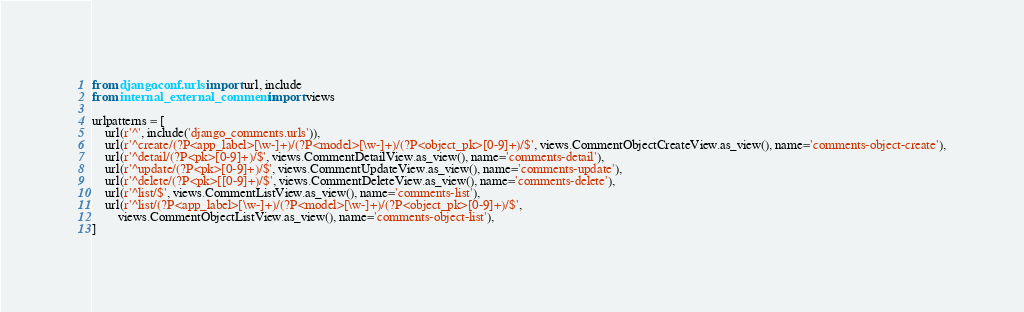<code> <loc_0><loc_0><loc_500><loc_500><_Python_>from django.conf.urls import url, include
from internal_external_comments import views

urlpatterns = [
    url(r'^', include('django_comments.urls')),
    url(r'^create/(?P<app_label>[\w-]+)/(?P<model>[\w-]+)/(?P<object_pk>[0-9]+)/$', views.CommentObjectCreateView.as_view(), name='comments-object-create'),
    url(r'^detail/(?P<pk>[0-9]+)/$', views.CommentDetailView.as_view(), name='comments-detail'),
    url(r'^update/(?P<pk>[0-9]+)/$', views.CommentUpdateView.as_view(), name='comments-update'),
    url(r'^delete/(?P<pk>[[0-9]+)/$', views.CommentDeleteView.as_view(), name='comments-delete'),
    url(r'^list/$', views.CommentListView.as_view(), name='comments-list'),
    url(r'^list/(?P<app_label>[\w-]+)/(?P<model>[\w-]+)/(?P<object_pk>[0-9]+)/$',
        views.CommentObjectListView.as_view(), name='comments-object-list'),
]
</code> 